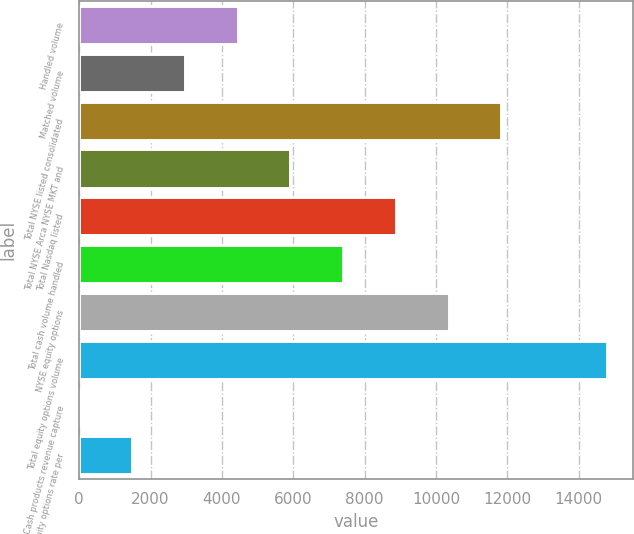<chart> <loc_0><loc_0><loc_500><loc_500><bar_chart><fcel>Handled volume<fcel>Matched volume<fcel>Total NYSE listed consolidated<fcel>Total NYSE Arca NYSE MKT and<fcel>Total Nasdaq listed<fcel>Total cash volume handled<fcel>NYSE equity options<fcel>Total equity options volume<fcel>Cash products revenue capture<fcel>Equity options rate per<nl><fcel>4437.93<fcel>2958.64<fcel>11834.4<fcel>5917.23<fcel>8875.82<fcel>7396.52<fcel>10355.1<fcel>14793<fcel>0.05<fcel>1479.35<nl></chart> 